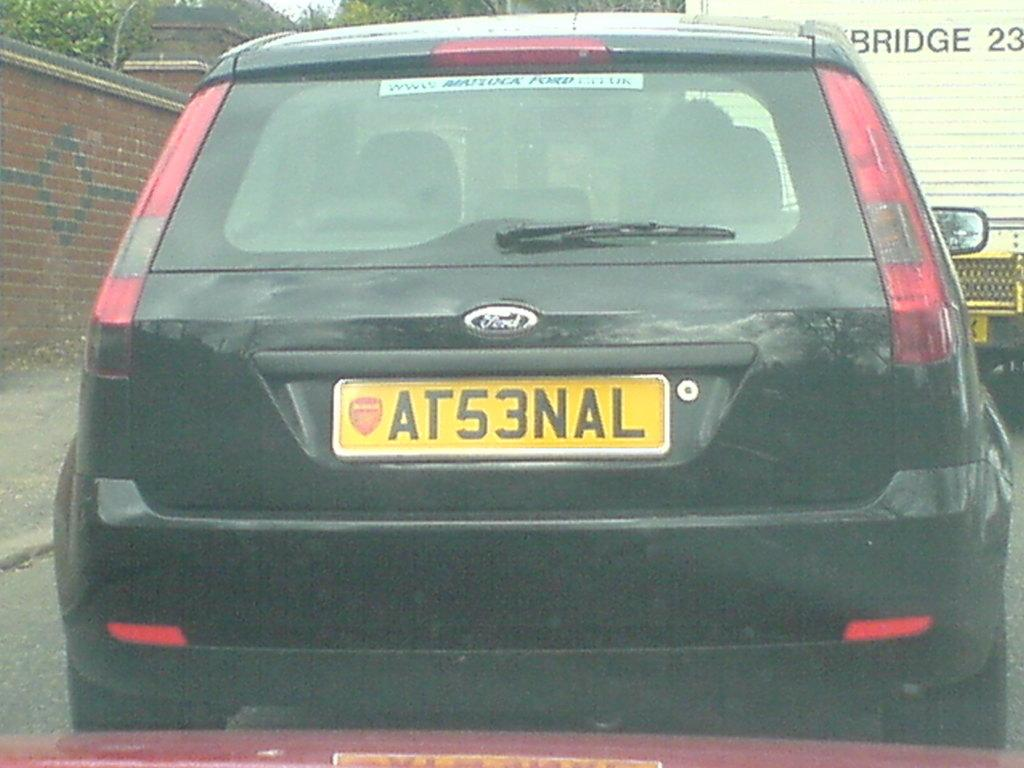Provide a one-sentence caption for the provided image. A black car says Ford on the back. 